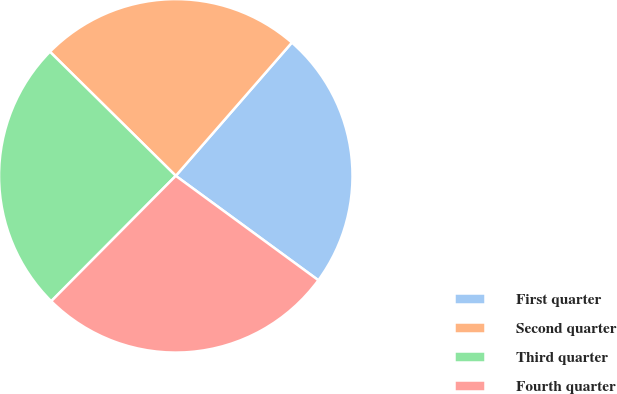Convert chart. <chart><loc_0><loc_0><loc_500><loc_500><pie_chart><fcel>First quarter<fcel>Second quarter<fcel>Third quarter<fcel>Fourth quarter<nl><fcel>23.65%<fcel>24.02%<fcel>24.94%<fcel>27.39%<nl></chart> 